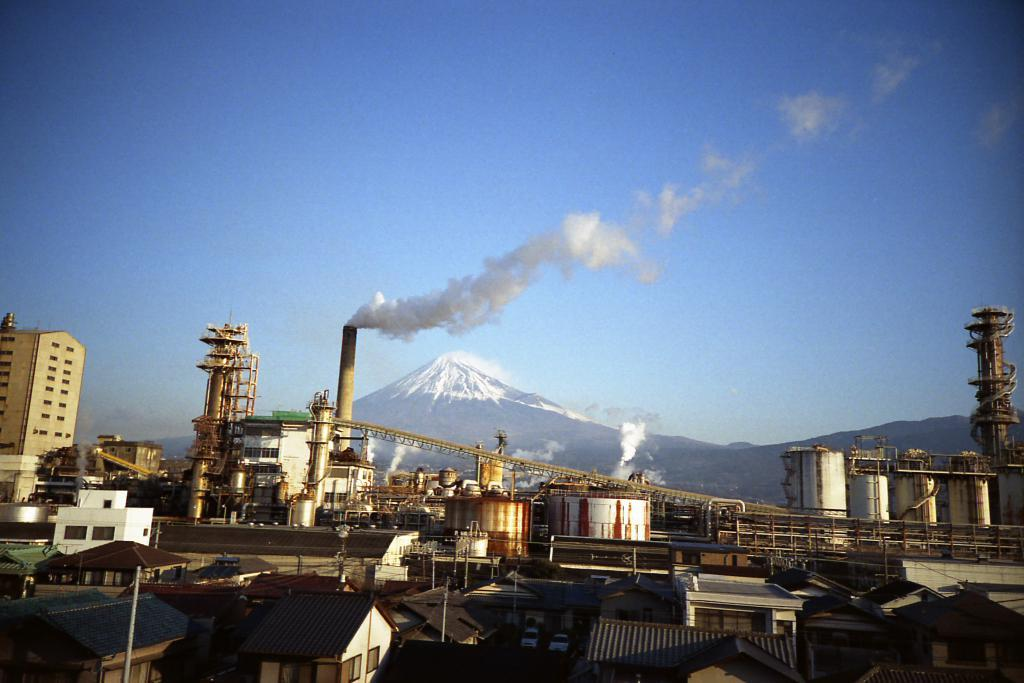What type of structures can be seen in the image? There are buildings and a factory in the image. Can you describe the landscape behind the factory? There is a snowy mountain behind the factory. What is visible in the background of the image? The sky is visible in the background of the image. How does the clam contribute to the factory's production process in the image? There are no clams present in the image, and therefore they cannot contribute to the factory's production process. 